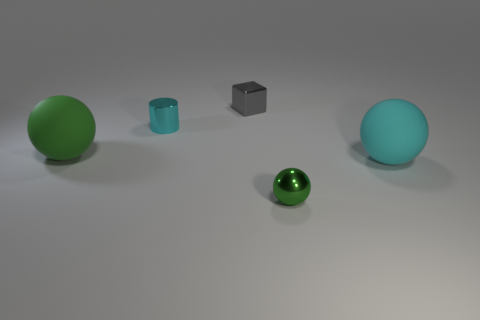There is a green sphere that is to the left of the tiny object in front of the large ball to the left of the small ball; what is it made of?
Keep it short and to the point. Rubber. How many rubber things are big cyan balls or large red objects?
Keep it short and to the point. 1. Is there a big brown metal thing?
Your answer should be compact. No. What is the color of the large rubber ball that is to the right of the big thing that is to the left of the big cyan rubber sphere?
Your answer should be compact. Cyan. How many other things are there of the same color as the cylinder?
Make the answer very short. 1. What number of things are either large green matte blocks or objects in front of the tiny gray shiny cube?
Provide a short and direct response. 4. There is a tiny metal object that is in front of the metallic cylinder; what color is it?
Give a very brief answer. Green. What is the shape of the tiny gray metal object?
Provide a short and direct response. Cube. There is a tiny green thing that is in front of the rubber ball that is in front of the large green matte object; what is its material?
Give a very brief answer. Metal. What number of other things are there of the same material as the cylinder
Your answer should be compact. 2. 